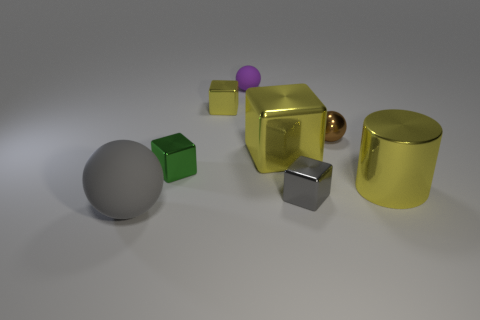Add 1 gray metal cubes. How many objects exist? 9 Subtract all spheres. How many objects are left? 5 Add 1 matte spheres. How many matte spheres exist? 3 Subtract 0 cyan blocks. How many objects are left? 8 Subtract all small purple matte objects. Subtract all small brown balls. How many objects are left? 6 Add 6 small gray metallic objects. How many small gray metallic objects are left? 7 